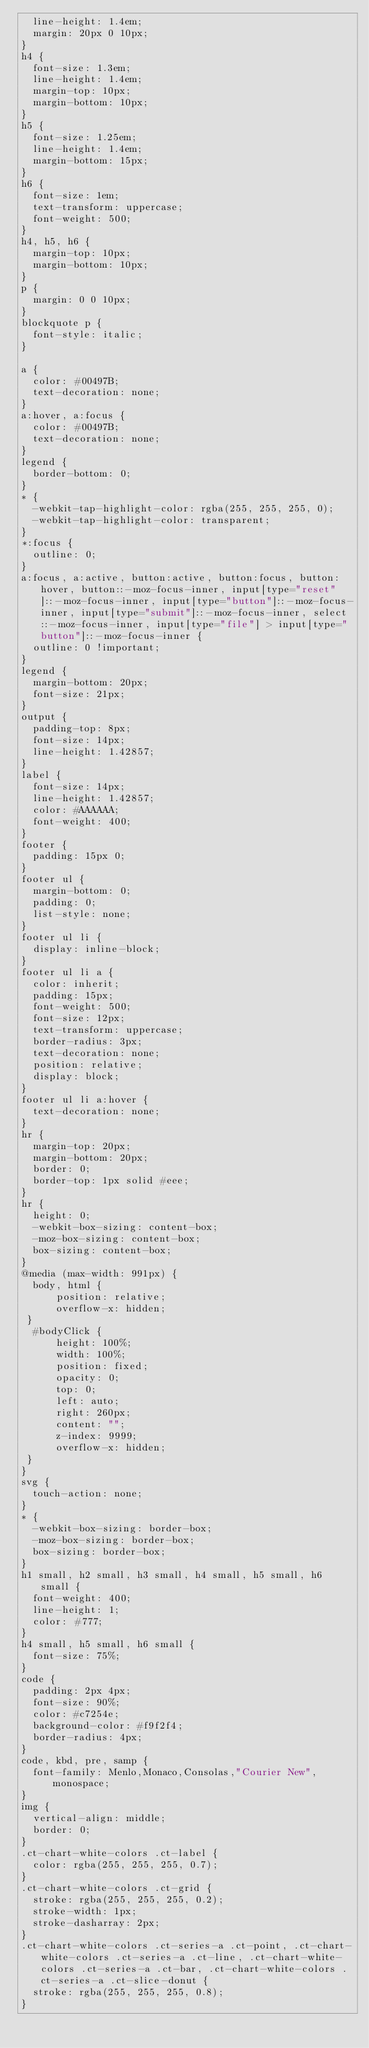Convert code to text. <code><loc_0><loc_0><loc_500><loc_500><_CSS_>  line-height: 1.4em;
  margin: 20px 0 10px;
}
h4 {
  font-size: 1.3em;
  line-height: 1.4em;
  margin-top: 10px;
  margin-bottom: 10px;
}
h5 {
  font-size: 1.25em;
  line-height: 1.4em;
  margin-bottom: 15px;
}
h6 {
  font-size: 1em;
  text-transform: uppercase;
  font-weight: 500;
}
h4, h5, h6 {
  margin-top: 10px;
  margin-bottom: 10px;
}
p {
  margin: 0 0 10px;
}
blockquote p {
  font-style: italic;
}

a {
  color: #00497B;
  text-decoration: none;
}
a:hover, a:focus {
  color: #00497B;
  text-decoration: none;
}
legend {
  border-bottom: 0;
}
* {
  -webkit-tap-highlight-color: rgba(255, 255, 255, 0);
  -webkit-tap-highlight-color: transparent;
}
*:focus {
  outline: 0;
}
a:focus, a:active, button:active, button:focus, button:hover, button::-moz-focus-inner, input[type="reset"]::-moz-focus-inner, input[type="button"]::-moz-focus-inner, input[type="submit"]::-moz-focus-inner, select::-moz-focus-inner, input[type="file"] > input[type="button"]::-moz-focus-inner {
  outline: 0 !important;
}
legend {
  margin-bottom: 20px;
  font-size: 21px;
}
output {
  padding-top: 8px;
  font-size: 14px;
  line-height: 1.42857;
}
label {
  font-size: 14px;
  line-height: 1.42857;
  color: #AAAAAA;
  font-weight: 400;
}
footer {
  padding: 15px 0;
}
footer ul {
  margin-bottom: 0;
  padding: 0;
  list-style: none;
}
footer ul li {
  display: inline-block;
}
footer ul li a {
  color: inherit;
  padding: 15px;
  font-weight: 500;
  font-size: 12px;
  text-transform: uppercase;
  border-radius: 3px;
  text-decoration: none;
  position: relative;
  display: block;
}
footer ul li a:hover {
  text-decoration: none;
}
hr {
  margin-top: 20px;
  margin-bottom: 20px;
  border: 0;
  border-top: 1px solid #eee;
}
hr {
  height: 0;
  -webkit-box-sizing: content-box;
  -moz-box-sizing: content-box;
  box-sizing: content-box;
}
@media (max-width: 991px) {
  body, html {
      position: relative;
      overflow-x: hidden;
 }
  #bodyClick {
      height: 100%;
      width: 100%;
      position: fixed;
      opacity: 0;
      top: 0;
      left: auto;
      right: 260px;
      content: "";
      z-index: 9999;
      overflow-x: hidden;
 }
}
svg {
  touch-action: none;
}
* {
  -webkit-box-sizing: border-box;
  -moz-box-sizing: border-box;
  box-sizing: border-box;
}
h1 small, h2 small, h3 small, h4 small, h5 small, h6 small {
  font-weight: 400;
  line-height: 1;
  color: #777;
}
h4 small, h5 small, h6 small {
  font-size: 75%;
}
code {
  padding: 2px 4px;
  font-size: 90%;
  color: #c7254e;
  background-color: #f9f2f4;
  border-radius: 4px;
}
code, kbd, pre, samp {
  font-family: Menlo,Monaco,Consolas,"Courier New",monospace;
}
img {
  vertical-align: middle;
  border: 0;
}
.ct-chart-white-colors .ct-label {
  color: rgba(255, 255, 255, 0.7);
}
.ct-chart-white-colors .ct-grid {
  stroke: rgba(255, 255, 255, 0.2);
  stroke-width: 1px;
  stroke-dasharray: 2px;
}
.ct-chart-white-colors .ct-series-a .ct-point, .ct-chart-white-colors .ct-series-a .ct-line, .ct-chart-white-colors .ct-series-a .ct-bar, .ct-chart-white-colors .ct-series-a .ct-slice-donut {
  stroke: rgba(255, 255, 255, 0.8);
}</code> 